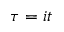Convert formula to latex. <formula><loc_0><loc_0><loc_500><loc_500>\tau = i t</formula> 